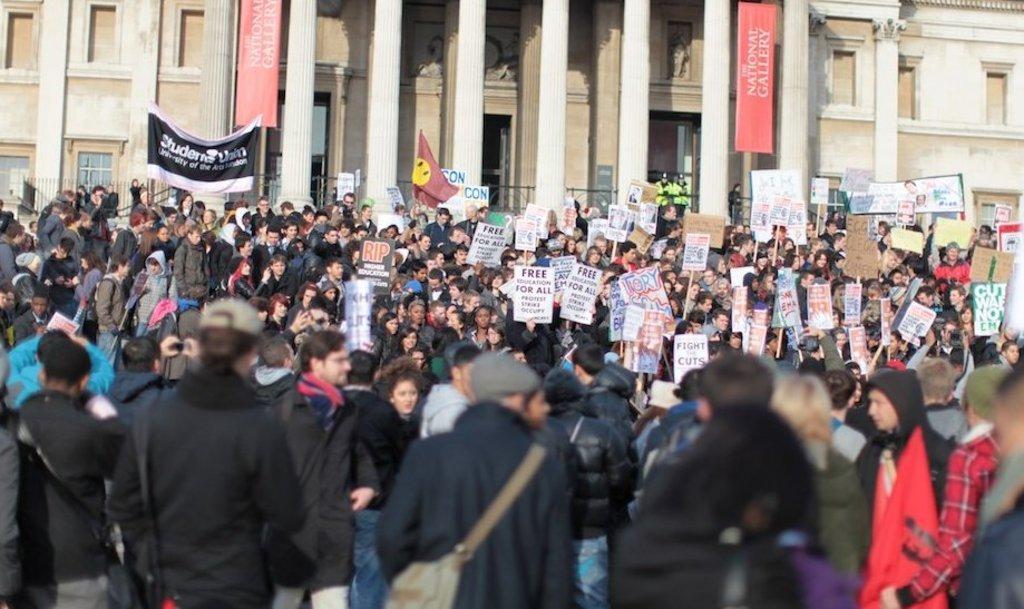How would you summarize this image in a sentence or two? In the picture there are many people present, they are holding many boards with the text, there are banners with the text, there is a building. 